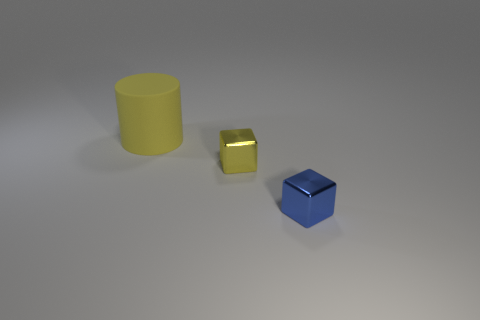Are there any tiny brown matte objects that have the same shape as the big yellow matte object?
Make the answer very short. No. There is a yellow thing that is the same size as the blue object; what is its shape?
Your response must be concise. Cube. How many large matte cylinders have the same color as the matte thing?
Make the answer very short. 0. What is the size of the metal cube that is behind the small blue metal thing?
Provide a short and direct response. Small. How many metal blocks are the same size as the yellow metallic object?
Your answer should be compact. 1. What color is the other tiny thing that is made of the same material as the blue object?
Give a very brief answer. Yellow. Are there fewer yellow objects on the right side of the tiny blue shiny cube than blocks?
Make the answer very short. Yes. The small yellow thing that is made of the same material as the blue object is what shape?
Your answer should be compact. Cube. What number of shiny objects are either yellow cylinders or large green balls?
Keep it short and to the point. 0. Is the number of tiny yellow metallic objects to the left of the small yellow metallic object the same as the number of tiny blue cubes?
Give a very brief answer. No. 